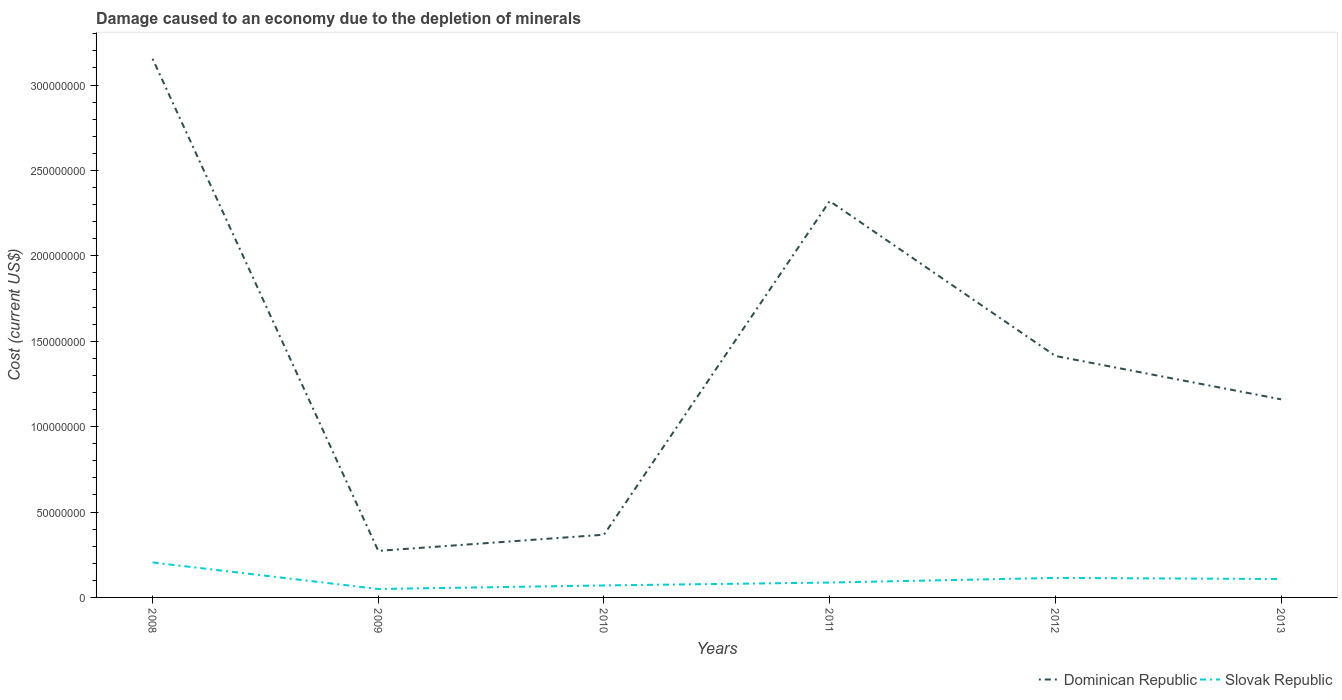Does the line corresponding to Dominican Republic intersect with the line corresponding to Slovak Republic?
Make the answer very short. No. Across all years, what is the maximum cost of damage caused due to the depletion of minerals in Dominican Republic?
Provide a succinct answer. 2.73e+07. In which year was the cost of damage caused due to the depletion of minerals in Slovak Republic maximum?
Provide a short and direct response. 2009. What is the total cost of damage caused due to the depletion of minerals in Dominican Republic in the graph?
Make the answer very short. -2.05e+08. What is the difference between the highest and the second highest cost of damage caused due to the depletion of minerals in Dominican Republic?
Make the answer very short. 2.88e+08. What is the difference between the highest and the lowest cost of damage caused due to the depletion of minerals in Dominican Republic?
Your answer should be very brief. 2. Is the cost of damage caused due to the depletion of minerals in Dominican Republic strictly greater than the cost of damage caused due to the depletion of minerals in Slovak Republic over the years?
Keep it short and to the point. No. How many years are there in the graph?
Your answer should be very brief. 6. Does the graph contain any zero values?
Provide a short and direct response. No. Does the graph contain grids?
Make the answer very short. No. Where does the legend appear in the graph?
Your answer should be compact. Bottom right. How many legend labels are there?
Make the answer very short. 2. What is the title of the graph?
Keep it short and to the point. Damage caused to an economy due to the depletion of minerals. Does "Eritrea" appear as one of the legend labels in the graph?
Your answer should be compact. No. What is the label or title of the Y-axis?
Give a very brief answer. Cost (current US$). What is the Cost (current US$) of Dominican Republic in 2008?
Give a very brief answer. 3.15e+08. What is the Cost (current US$) in Slovak Republic in 2008?
Offer a very short reply. 2.05e+07. What is the Cost (current US$) in Dominican Republic in 2009?
Keep it short and to the point. 2.73e+07. What is the Cost (current US$) of Slovak Republic in 2009?
Ensure brevity in your answer.  4.94e+06. What is the Cost (current US$) in Dominican Republic in 2010?
Give a very brief answer. 3.67e+07. What is the Cost (current US$) of Slovak Republic in 2010?
Offer a very short reply. 7.02e+06. What is the Cost (current US$) of Dominican Republic in 2011?
Provide a short and direct response. 2.32e+08. What is the Cost (current US$) in Slovak Republic in 2011?
Your answer should be very brief. 8.71e+06. What is the Cost (current US$) of Dominican Republic in 2012?
Offer a very short reply. 1.41e+08. What is the Cost (current US$) of Slovak Republic in 2012?
Ensure brevity in your answer.  1.14e+07. What is the Cost (current US$) in Dominican Republic in 2013?
Provide a short and direct response. 1.16e+08. What is the Cost (current US$) of Slovak Republic in 2013?
Your answer should be very brief. 1.08e+07. Across all years, what is the maximum Cost (current US$) of Dominican Republic?
Ensure brevity in your answer.  3.15e+08. Across all years, what is the maximum Cost (current US$) in Slovak Republic?
Make the answer very short. 2.05e+07. Across all years, what is the minimum Cost (current US$) in Dominican Republic?
Offer a terse response. 2.73e+07. Across all years, what is the minimum Cost (current US$) of Slovak Republic?
Offer a very short reply. 4.94e+06. What is the total Cost (current US$) in Dominican Republic in the graph?
Give a very brief answer. 8.69e+08. What is the total Cost (current US$) of Slovak Republic in the graph?
Provide a succinct answer. 6.33e+07. What is the difference between the Cost (current US$) in Dominican Republic in 2008 and that in 2009?
Give a very brief answer. 2.88e+08. What is the difference between the Cost (current US$) in Slovak Republic in 2008 and that in 2009?
Offer a terse response. 1.55e+07. What is the difference between the Cost (current US$) of Dominican Republic in 2008 and that in 2010?
Keep it short and to the point. 2.79e+08. What is the difference between the Cost (current US$) in Slovak Republic in 2008 and that in 2010?
Keep it short and to the point. 1.34e+07. What is the difference between the Cost (current US$) of Dominican Republic in 2008 and that in 2011?
Keep it short and to the point. 8.33e+07. What is the difference between the Cost (current US$) of Slovak Republic in 2008 and that in 2011?
Your answer should be very brief. 1.18e+07. What is the difference between the Cost (current US$) of Dominican Republic in 2008 and that in 2012?
Your answer should be very brief. 1.74e+08. What is the difference between the Cost (current US$) in Slovak Republic in 2008 and that in 2012?
Keep it short and to the point. 9.04e+06. What is the difference between the Cost (current US$) of Dominican Republic in 2008 and that in 2013?
Ensure brevity in your answer.  1.99e+08. What is the difference between the Cost (current US$) in Slovak Republic in 2008 and that in 2013?
Provide a succinct answer. 9.69e+06. What is the difference between the Cost (current US$) in Dominican Republic in 2009 and that in 2010?
Your response must be concise. -9.47e+06. What is the difference between the Cost (current US$) of Slovak Republic in 2009 and that in 2010?
Ensure brevity in your answer.  -2.08e+06. What is the difference between the Cost (current US$) in Dominican Republic in 2009 and that in 2011?
Ensure brevity in your answer.  -2.05e+08. What is the difference between the Cost (current US$) in Slovak Republic in 2009 and that in 2011?
Ensure brevity in your answer.  -3.77e+06. What is the difference between the Cost (current US$) of Dominican Republic in 2009 and that in 2012?
Provide a succinct answer. -1.14e+08. What is the difference between the Cost (current US$) in Slovak Republic in 2009 and that in 2012?
Make the answer very short. -6.49e+06. What is the difference between the Cost (current US$) of Dominican Republic in 2009 and that in 2013?
Give a very brief answer. -8.87e+07. What is the difference between the Cost (current US$) of Slovak Republic in 2009 and that in 2013?
Offer a terse response. -5.83e+06. What is the difference between the Cost (current US$) of Dominican Republic in 2010 and that in 2011?
Your response must be concise. -1.95e+08. What is the difference between the Cost (current US$) of Slovak Republic in 2010 and that in 2011?
Your answer should be very brief. -1.68e+06. What is the difference between the Cost (current US$) of Dominican Republic in 2010 and that in 2012?
Give a very brief answer. -1.05e+08. What is the difference between the Cost (current US$) in Slovak Republic in 2010 and that in 2012?
Provide a succinct answer. -4.40e+06. What is the difference between the Cost (current US$) in Dominican Republic in 2010 and that in 2013?
Give a very brief answer. -7.93e+07. What is the difference between the Cost (current US$) of Slovak Republic in 2010 and that in 2013?
Provide a succinct answer. -3.75e+06. What is the difference between the Cost (current US$) in Dominican Republic in 2011 and that in 2012?
Provide a succinct answer. 9.07e+07. What is the difference between the Cost (current US$) of Slovak Republic in 2011 and that in 2012?
Ensure brevity in your answer.  -2.72e+06. What is the difference between the Cost (current US$) of Dominican Republic in 2011 and that in 2013?
Offer a very short reply. 1.16e+08. What is the difference between the Cost (current US$) in Slovak Republic in 2011 and that in 2013?
Your answer should be compact. -2.06e+06. What is the difference between the Cost (current US$) of Dominican Republic in 2012 and that in 2013?
Keep it short and to the point. 2.54e+07. What is the difference between the Cost (current US$) of Slovak Republic in 2012 and that in 2013?
Keep it short and to the point. 6.55e+05. What is the difference between the Cost (current US$) in Dominican Republic in 2008 and the Cost (current US$) in Slovak Republic in 2009?
Keep it short and to the point. 3.10e+08. What is the difference between the Cost (current US$) in Dominican Republic in 2008 and the Cost (current US$) in Slovak Republic in 2010?
Provide a short and direct response. 3.08e+08. What is the difference between the Cost (current US$) in Dominican Republic in 2008 and the Cost (current US$) in Slovak Republic in 2011?
Offer a terse response. 3.07e+08. What is the difference between the Cost (current US$) of Dominican Republic in 2008 and the Cost (current US$) of Slovak Republic in 2012?
Keep it short and to the point. 3.04e+08. What is the difference between the Cost (current US$) of Dominican Republic in 2008 and the Cost (current US$) of Slovak Republic in 2013?
Keep it short and to the point. 3.05e+08. What is the difference between the Cost (current US$) of Dominican Republic in 2009 and the Cost (current US$) of Slovak Republic in 2010?
Offer a terse response. 2.02e+07. What is the difference between the Cost (current US$) of Dominican Republic in 2009 and the Cost (current US$) of Slovak Republic in 2011?
Offer a terse response. 1.85e+07. What is the difference between the Cost (current US$) of Dominican Republic in 2009 and the Cost (current US$) of Slovak Republic in 2012?
Offer a terse response. 1.58e+07. What is the difference between the Cost (current US$) in Dominican Republic in 2009 and the Cost (current US$) in Slovak Republic in 2013?
Ensure brevity in your answer.  1.65e+07. What is the difference between the Cost (current US$) of Dominican Republic in 2010 and the Cost (current US$) of Slovak Republic in 2011?
Ensure brevity in your answer.  2.80e+07. What is the difference between the Cost (current US$) of Dominican Republic in 2010 and the Cost (current US$) of Slovak Republic in 2012?
Give a very brief answer. 2.53e+07. What is the difference between the Cost (current US$) of Dominican Republic in 2010 and the Cost (current US$) of Slovak Republic in 2013?
Your answer should be compact. 2.60e+07. What is the difference between the Cost (current US$) in Dominican Republic in 2011 and the Cost (current US$) in Slovak Republic in 2012?
Give a very brief answer. 2.21e+08. What is the difference between the Cost (current US$) in Dominican Republic in 2011 and the Cost (current US$) in Slovak Republic in 2013?
Provide a short and direct response. 2.21e+08. What is the difference between the Cost (current US$) in Dominican Republic in 2012 and the Cost (current US$) in Slovak Republic in 2013?
Provide a succinct answer. 1.31e+08. What is the average Cost (current US$) in Dominican Republic per year?
Your response must be concise. 1.45e+08. What is the average Cost (current US$) of Slovak Republic per year?
Ensure brevity in your answer.  1.06e+07. In the year 2008, what is the difference between the Cost (current US$) in Dominican Republic and Cost (current US$) in Slovak Republic?
Your response must be concise. 2.95e+08. In the year 2009, what is the difference between the Cost (current US$) of Dominican Republic and Cost (current US$) of Slovak Republic?
Make the answer very short. 2.23e+07. In the year 2010, what is the difference between the Cost (current US$) in Dominican Republic and Cost (current US$) in Slovak Republic?
Ensure brevity in your answer.  2.97e+07. In the year 2011, what is the difference between the Cost (current US$) in Dominican Republic and Cost (current US$) in Slovak Republic?
Your answer should be compact. 2.23e+08. In the year 2012, what is the difference between the Cost (current US$) in Dominican Republic and Cost (current US$) in Slovak Republic?
Offer a terse response. 1.30e+08. In the year 2013, what is the difference between the Cost (current US$) of Dominican Republic and Cost (current US$) of Slovak Republic?
Offer a terse response. 1.05e+08. What is the ratio of the Cost (current US$) of Dominican Republic in 2008 to that in 2009?
Keep it short and to the point. 11.57. What is the ratio of the Cost (current US$) in Slovak Republic in 2008 to that in 2009?
Ensure brevity in your answer.  4.14. What is the ratio of the Cost (current US$) in Dominican Republic in 2008 to that in 2010?
Offer a very short reply. 8.59. What is the ratio of the Cost (current US$) in Slovak Republic in 2008 to that in 2010?
Ensure brevity in your answer.  2.91. What is the ratio of the Cost (current US$) in Dominican Republic in 2008 to that in 2011?
Provide a succinct answer. 1.36. What is the ratio of the Cost (current US$) of Slovak Republic in 2008 to that in 2011?
Ensure brevity in your answer.  2.35. What is the ratio of the Cost (current US$) in Dominican Republic in 2008 to that in 2012?
Provide a succinct answer. 2.23. What is the ratio of the Cost (current US$) in Slovak Republic in 2008 to that in 2012?
Make the answer very short. 1.79. What is the ratio of the Cost (current US$) of Dominican Republic in 2008 to that in 2013?
Your answer should be very brief. 2.72. What is the ratio of the Cost (current US$) in Slovak Republic in 2008 to that in 2013?
Your answer should be compact. 1.9. What is the ratio of the Cost (current US$) in Dominican Republic in 2009 to that in 2010?
Offer a very short reply. 0.74. What is the ratio of the Cost (current US$) in Slovak Republic in 2009 to that in 2010?
Give a very brief answer. 0.7. What is the ratio of the Cost (current US$) in Dominican Republic in 2009 to that in 2011?
Give a very brief answer. 0.12. What is the ratio of the Cost (current US$) of Slovak Republic in 2009 to that in 2011?
Your response must be concise. 0.57. What is the ratio of the Cost (current US$) of Dominican Republic in 2009 to that in 2012?
Your response must be concise. 0.19. What is the ratio of the Cost (current US$) in Slovak Republic in 2009 to that in 2012?
Keep it short and to the point. 0.43. What is the ratio of the Cost (current US$) in Dominican Republic in 2009 to that in 2013?
Your answer should be compact. 0.23. What is the ratio of the Cost (current US$) of Slovak Republic in 2009 to that in 2013?
Your answer should be compact. 0.46. What is the ratio of the Cost (current US$) of Dominican Republic in 2010 to that in 2011?
Keep it short and to the point. 0.16. What is the ratio of the Cost (current US$) of Slovak Republic in 2010 to that in 2011?
Offer a terse response. 0.81. What is the ratio of the Cost (current US$) in Dominican Republic in 2010 to that in 2012?
Keep it short and to the point. 0.26. What is the ratio of the Cost (current US$) of Slovak Republic in 2010 to that in 2012?
Ensure brevity in your answer.  0.61. What is the ratio of the Cost (current US$) of Dominican Republic in 2010 to that in 2013?
Keep it short and to the point. 0.32. What is the ratio of the Cost (current US$) in Slovak Republic in 2010 to that in 2013?
Give a very brief answer. 0.65. What is the ratio of the Cost (current US$) in Dominican Republic in 2011 to that in 2012?
Ensure brevity in your answer.  1.64. What is the ratio of the Cost (current US$) of Slovak Republic in 2011 to that in 2012?
Your response must be concise. 0.76. What is the ratio of the Cost (current US$) in Dominican Republic in 2011 to that in 2013?
Provide a short and direct response. 2. What is the ratio of the Cost (current US$) of Slovak Republic in 2011 to that in 2013?
Your answer should be compact. 0.81. What is the ratio of the Cost (current US$) in Dominican Republic in 2012 to that in 2013?
Keep it short and to the point. 1.22. What is the ratio of the Cost (current US$) in Slovak Republic in 2012 to that in 2013?
Provide a short and direct response. 1.06. What is the difference between the highest and the second highest Cost (current US$) in Dominican Republic?
Provide a succinct answer. 8.33e+07. What is the difference between the highest and the second highest Cost (current US$) of Slovak Republic?
Give a very brief answer. 9.04e+06. What is the difference between the highest and the lowest Cost (current US$) in Dominican Republic?
Give a very brief answer. 2.88e+08. What is the difference between the highest and the lowest Cost (current US$) in Slovak Republic?
Keep it short and to the point. 1.55e+07. 